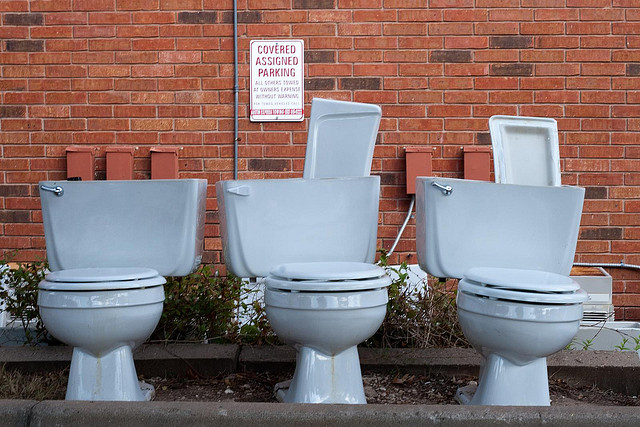Identify and read out the text in this image. COVERED ASSIGNED PARKING ALL 